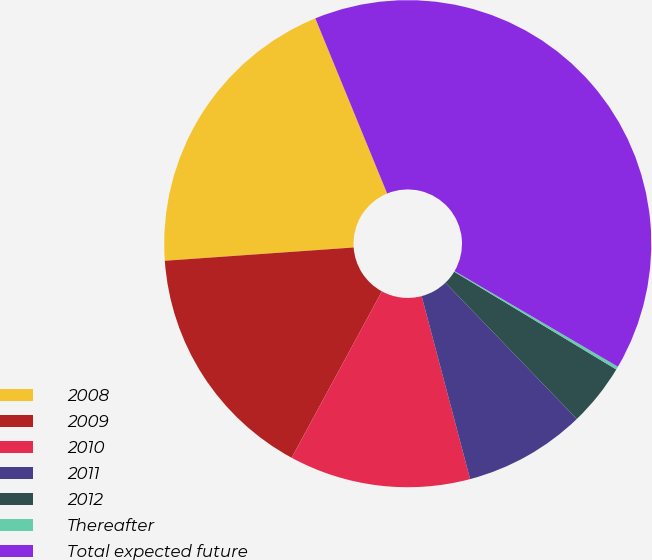<chart> <loc_0><loc_0><loc_500><loc_500><pie_chart><fcel>2008<fcel>2009<fcel>2010<fcel>2011<fcel>2012<fcel>Thereafter<fcel>Total expected future<nl><fcel>19.92%<fcel>15.97%<fcel>12.03%<fcel>8.09%<fcel>4.15%<fcel>0.21%<fcel>39.62%<nl></chart> 